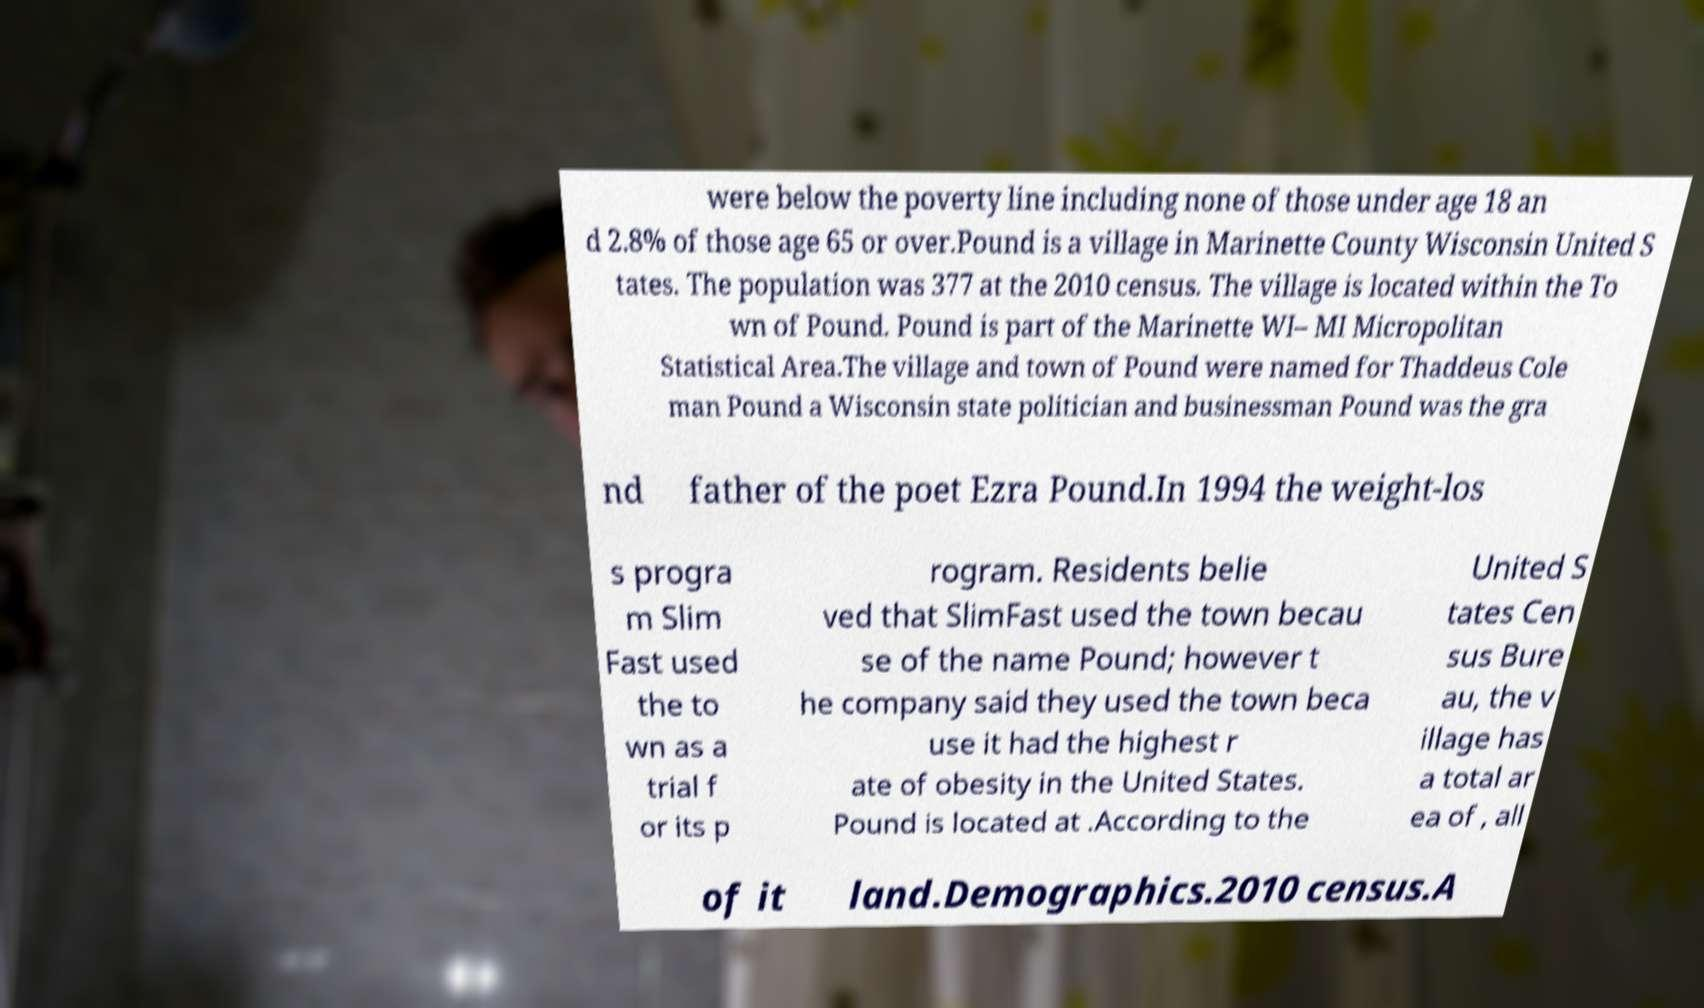What messages or text are displayed in this image? I need them in a readable, typed format. were below the poverty line including none of those under age 18 an d 2.8% of those age 65 or over.Pound is a village in Marinette County Wisconsin United S tates. The population was 377 at the 2010 census. The village is located within the To wn of Pound. Pound is part of the Marinette WI– MI Micropolitan Statistical Area.The village and town of Pound were named for Thaddeus Cole man Pound a Wisconsin state politician and businessman Pound was the gra nd father of the poet Ezra Pound.In 1994 the weight-los s progra m Slim Fast used the to wn as a trial f or its p rogram. Residents belie ved that SlimFast used the town becau se of the name Pound; however t he company said they used the town beca use it had the highest r ate of obesity in the United States. Pound is located at .According to the United S tates Cen sus Bure au, the v illage has a total ar ea of , all of it land.Demographics.2010 census.A 